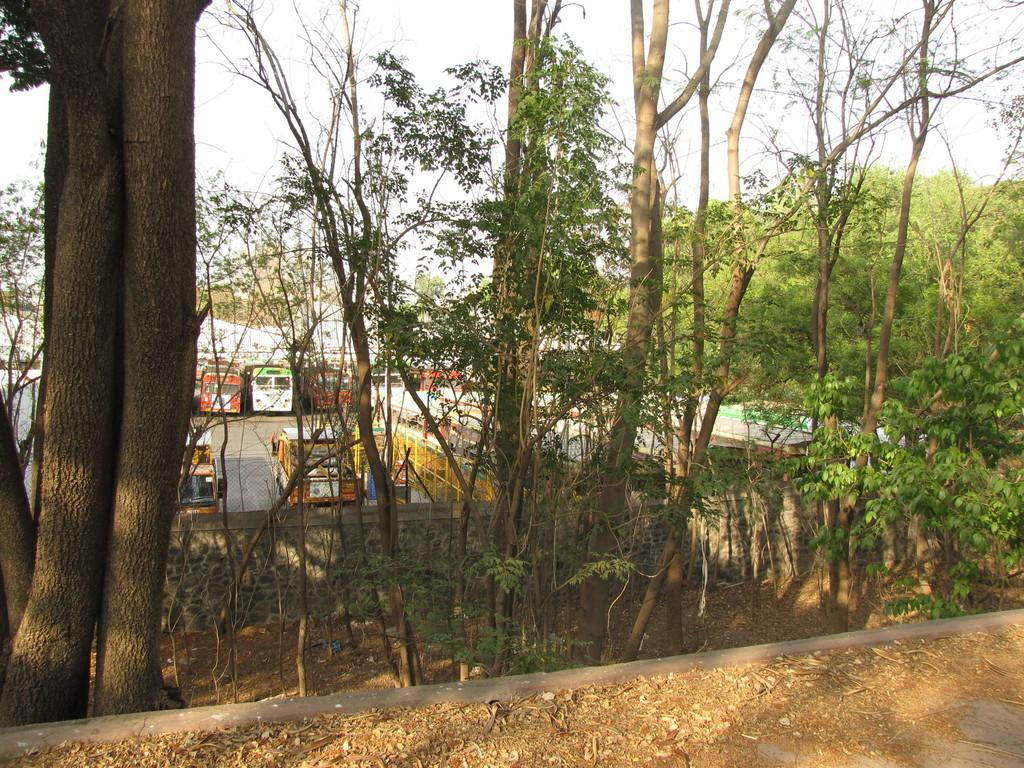What can be seen behind the wall in the image? There are buses behind the wall in the image. What type of vegetation is present in the image? There are trees in the image. What is visible at the top of the image? The sky is visible at the top of the image. What type of terrain is visible at the bottom of the image? There is mud visible at the bottom of the image. What color are the eyes of the leather jacket in the image? There is no leather jacket or eyes present in the image. How does the drop of water affect the buses in the image? There is no drop of water present in the image, so it cannot affect the buses. 